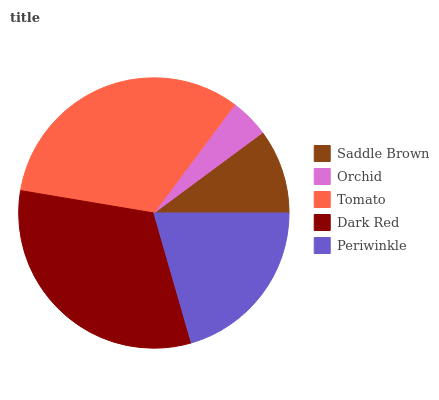Is Orchid the minimum?
Answer yes or no. Yes. Is Tomato the maximum?
Answer yes or no. Yes. Is Tomato the minimum?
Answer yes or no. No. Is Orchid the maximum?
Answer yes or no. No. Is Tomato greater than Orchid?
Answer yes or no. Yes. Is Orchid less than Tomato?
Answer yes or no. Yes. Is Orchid greater than Tomato?
Answer yes or no. No. Is Tomato less than Orchid?
Answer yes or no. No. Is Periwinkle the high median?
Answer yes or no. Yes. Is Periwinkle the low median?
Answer yes or no. Yes. Is Saddle Brown the high median?
Answer yes or no. No. Is Saddle Brown the low median?
Answer yes or no. No. 